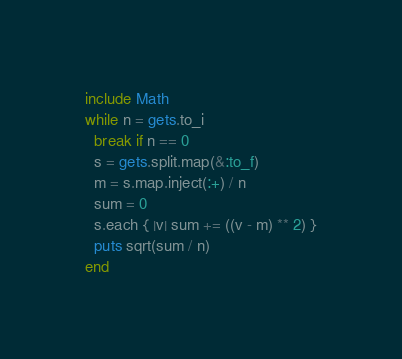Convert code to text. <code><loc_0><loc_0><loc_500><loc_500><_Ruby_>include Math
while n = gets.to_i
  break if n == 0
  s = gets.split.map(&:to_f)
  m = s.map.inject(:+) / n
  sum = 0
  s.each { |v| sum += ((v - m) ** 2) }
  puts sqrt(sum / n)
end</code> 